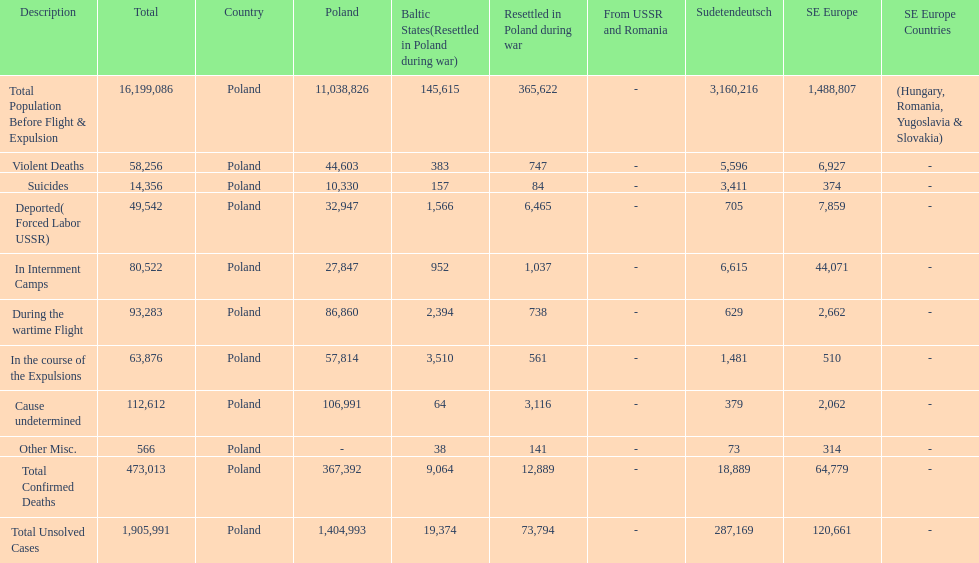Was there a larger total population before expulsion in poland or sudetendeutsch? Poland. 